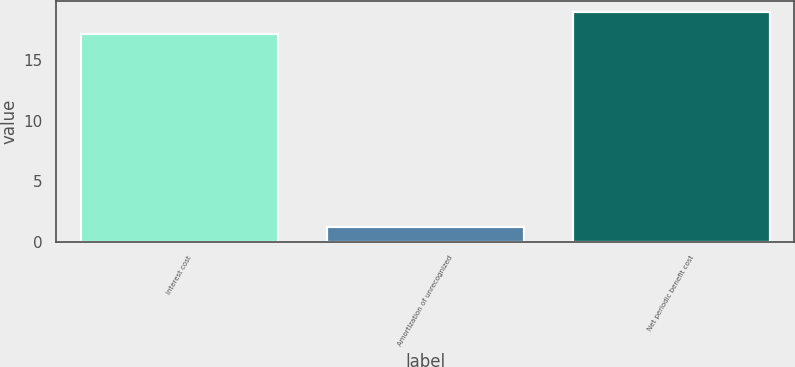Convert chart to OTSL. <chart><loc_0><loc_0><loc_500><loc_500><bar_chart><fcel>Interest cost<fcel>Amortization of unrecognized<fcel>Net periodic benefit cost<nl><fcel>17.2<fcel>1.2<fcel>18.95<nl></chart> 